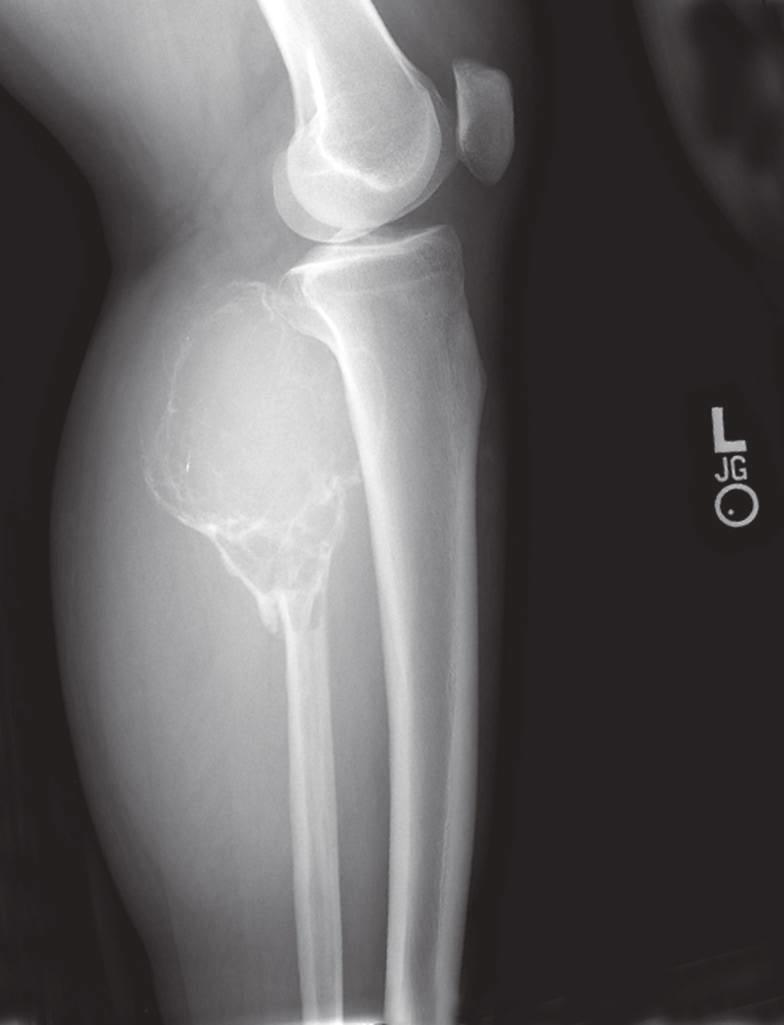s focal anaplasia also present?
Answer the question using a single word or phrase. No 